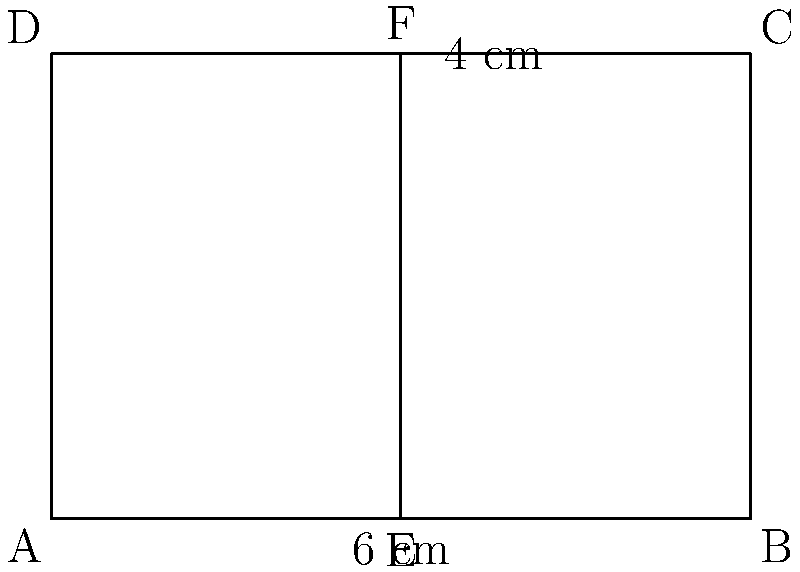When cutting a Cuban sandwich diagonally, how can you prove that the two halves are congruent? Consider the rectangular sandwich shown in the diagram, where the diagonal cut is represented by line EF. To prove that the two halves of the Cuban sandwich are congruent when cut diagonally, we can follow these steps:

1. Identify the properties of the rectangle ABCD:
   - Opposite sides are parallel and equal in length
   - All angles are 90°

2. Observe that line EF is a diagonal of the rectangle, connecting opposite corners.

3. The diagonal EF creates two triangles: AEF and BFC.

4. These triangles are congruent because:
   a) They share the common side EF
   b) Angle AEF = Angle BFC (both are right angles as they're formed by the diagonal and the sides of the rectangle)
   c) Angle EAF = Angle FBC (alternate angles, as AB is parallel to DC)

5. By the AAS (Angle-Angle-Side) congruence theorem, triangles AEF and BFC are congruent.

6. Congruent triangles have equal areas and corresponding sides and angles.

Therefore, when the Cuban sandwich is cut diagonally, the resulting halves (represented by triangles AEF and BFC) are congruent, ensuring equal portions with identical shape and size.
Answer: AAS congruence theorem 